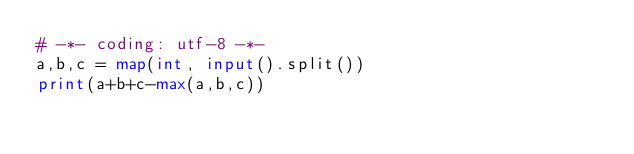<code> <loc_0><loc_0><loc_500><loc_500><_Python_># -*- coding: utf-8 -*-
a,b,c = map(int, input().split())
print(a+b+c-max(a,b,c))
</code> 